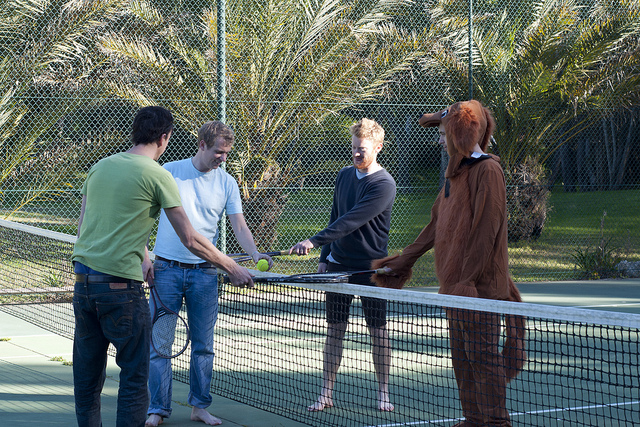Please provide a short description for this region: [0.58, 0.32, 0.82, 0.83]. The person on the right side. 